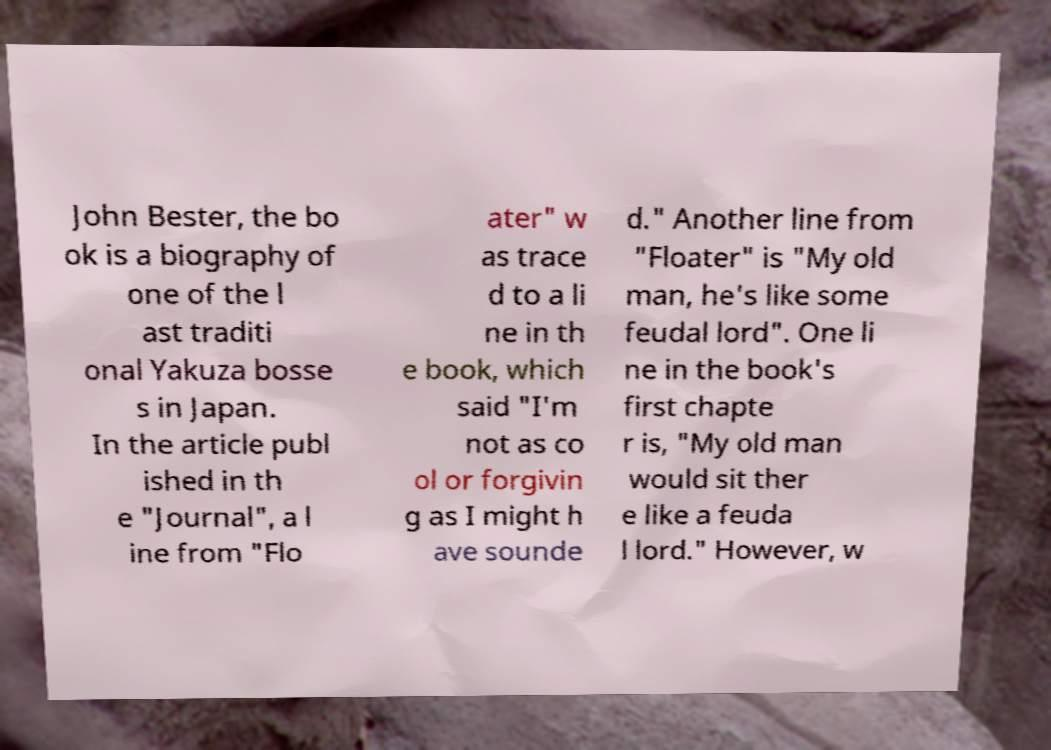For documentation purposes, I need the text within this image transcribed. Could you provide that? John Bester, the bo ok is a biography of one of the l ast traditi onal Yakuza bosse s in Japan. In the article publ ished in th e "Journal", a l ine from "Flo ater" w as trace d to a li ne in th e book, which said "I'm not as co ol or forgivin g as I might h ave sounde d." Another line from "Floater" is "My old man, he's like some feudal lord". One li ne in the book's first chapte r is, "My old man would sit ther e like a feuda l lord." However, w 